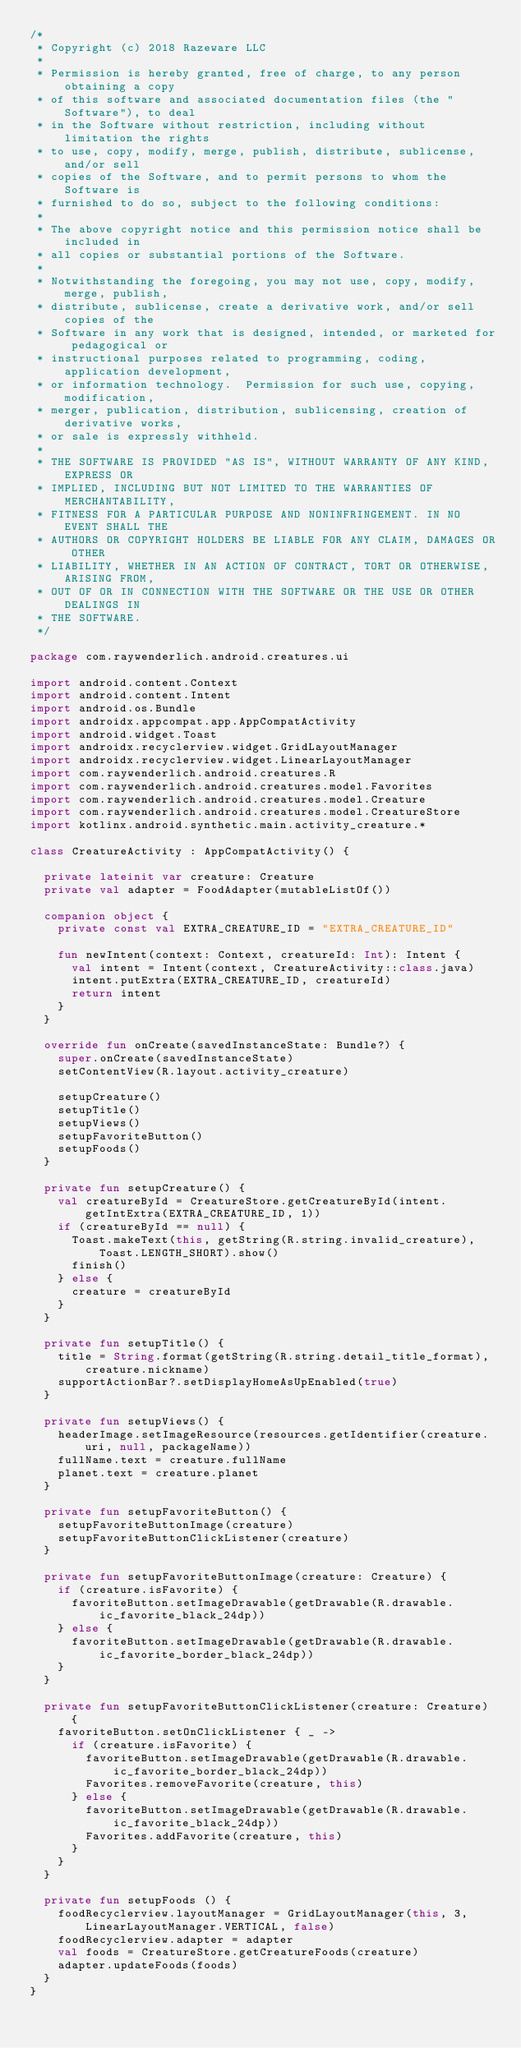<code> <loc_0><loc_0><loc_500><loc_500><_Kotlin_>/*
 * Copyright (c) 2018 Razeware LLC
 *
 * Permission is hereby granted, free of charge, to any person obtaining a copy
 * of this software and associated documentation files (the "Software"), to deal
 * in the Software without restriction, including without limitation the rights
 * to use, copy, modify, merge, publish, distribute, sublicense, and/or sell
 * copies of the Software, and to permit persons to whom the Software is
 * furnished to do so, subject to the following conditions:
 *
 * The above copyright notice and this permission notice shall be included in
 * all copies or substantial portions of the Software.
 *
 * Notwithstanding the foregoing, you may not use, copy, modify, merge, publish,
 * distribute, sublicense, create a derivative work, and/or sell copies of the
 * Software in any work that is designed, intended, or marketed for pedagogical or
 * instructional purposes related to programming, coding, application development,
 * or information technology.  Permission for such use, copying, modification,
 * merger, publication, distribution, sublicensing, creation of derivative works,
 * or sale is expressly withheld.
 *
 * THE SOFTWARE IS PROVIDED "AS IS", WITHOUT WARRANTY OF ANY KIND, EXPRESS OR
 * IMPLIED, INCLUDING BUT NOT LIMITED TO THE WARRANTIES OF MERCHANTABILITY,
 * FITNESS FOR A PARTICULAR PURPOSE AND NONINFRINGEMENT. IN NO EVENT SHALL THE
 * AUTHORS OR COPYRIGHT HOLDERS BE LIABLE FOR ANY CLAIM, DAMAGES OR OTHER
 * LIABILITY, WHETHER IN AN ACTION OF CONTRACT, TORT OR OTHERWISE, ARISING FROM,
 * OUT OF OR IN CONNECTION WITH THE SOFTWARE OR THE USE OR OTHER DEALINGS IN
 * THE SOFTWARE.
 */

package com.raywenderlich.android.creatures.ui

import android.content.Context
import android.content.Intent
import android.os.Bundle
import androidx.appcompat.app.AppCompatActivity
import android.widget.Toast
import androidx.recyclerview.widget.GridLayoutManager
import androidx.recyclerview.widget.LinearLayoutManager
import com.raywenderlich.android.creatures.R
import com.raywenderlich.android.creatures.model.Favorites
import com.raywenderlich.android.creatures.model.Creature
import com.raywenderlich.android.creatures.model.CreatureStore
import kotlinx.android.synthetic.main.activity_creature.*

class CreatureActivity : AppCompatActivity() {

  private lateinit var creature: Creature
  private val adapter = FoodAdapter(mutableListOf())

  companion object {
    private const val EXTRA_CREATURE_ID = "EXTRA_CREATURE_ID"

    fun newIntent(context: Context, creatureId: Int): Intent {
      val intent = Intent(context, CreatureActivity::class.java)
      intent.putExtra(EXTRA_CREATURE_ID, creatureId)
      return intent
    }
  }

  override fun onCreate(savedInstanceState: Bundle?) {
    super.onCreate(savedInstanceState)
    setContentView(R.layout.activity_creature)

    setupCreature()
    setupTitle()
    setupViews()
    setupFavoriteButton()
    setupFoods()
  }

  private fun setupCreature() {
    val creatureById = CreatureStore.getCreatureById(intent.getIntExtra(EXTRA_CREATURE_ID, 1))
    if (creatureById == null) {
      Toast.makeText(this, getString(R.string.invalid_creature), Toast.LENGTH_SHORT).show()
      finish()
    } else {
      creature = creatureById
    }
  }

  private fun setupTitle() {
    title = String.format(getString(R.string.detail_title_format), creature.nickname)
    supportActionBar?.setDisplayHomeAsUpEnabled(true)
  }

  private fun setupViews() {
    headerImage.setImageResource(resources.getIdentifier(creature.uri, null, packageName))
    fullName.text = creature.fullName
    planet.text = creature.planet
  }

  private fun setupFavoriteButton() {
    setupFavoriteButtonImage(creature)
    setupFavoriteButtonClickListener(creature)
  }

  private fun setupFavoriteButtonImage(creature: Creature) {
    if (creature.isFavorite) {
      favoriteButton.setImageDrawable(getDrawable(R.drawable.ic_favorite_black_24dp))
    } else {
      favoriteButton.setImageDrawable(getDrawable(R.drawable.ic_favorite_border_black_24dp))
    }
  }

  private fun setupFavoriteButtonClickListener(creature: Creature) {
    favoriteButton.setOnClickListener { _ ->
      if (creature.isFavorite) {
        favoriteButton.setImageDrawable(getDrawable(R.drawable.ic_favorite_border_black_24dp))
        Favorites.removeFavorite(creature, this)
      } else {
        favoriteButton.setImageDrawable(getDrawable(R.drawable.ic_favorite_black_24dp))
        Favorites.addFavorite(creature, this)
      }
    }
  }

  private fun setupFoods () {
    foodRecyclerview.layoutManager = GridLayoutManager(this, 3, LinearLayoutManager.VERTICAL, false)
    foodRecyclerview.adapter = adapter
    val foods = CreatureStore.getCreatureFoods(creature)
    adapter.updateFoods(foods)
  }
}
</code> 